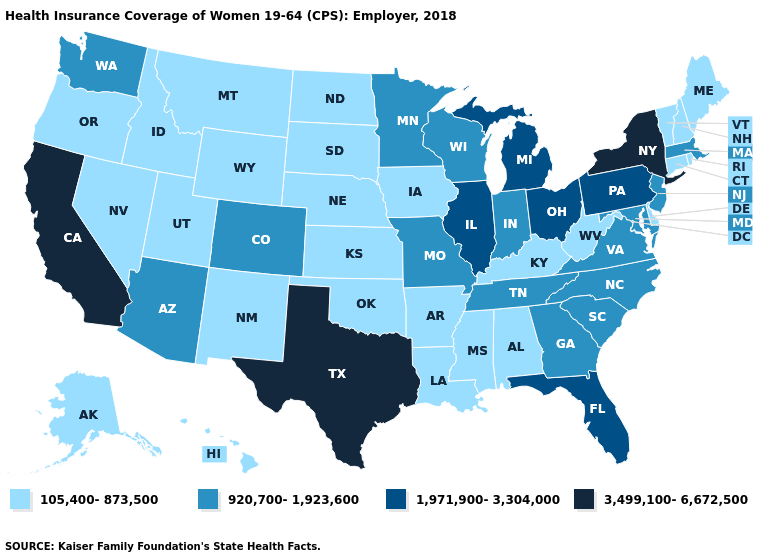What is the value of Rhode Island?
Give a very brief answer. 105,400-873,500. What is the value of Maryland?
Keep it brief. 920,700-1,923,600. Name the states that have a value in the range 3,499,100-6,672,500?
Keep it brief. California, New York, Texas. Does the first symbol in the legend represent the smallest category?
Keep it brief. Yes. Which states have the lowest value in the MidWest?
Answer briefly. Iowa, Kansas, Nebraska, North Dakota, South Dakota. Does the first symbol in the legend represent the smallest category?
Concise answer only. Yes. Name the states that have a value in the range 1,971,900-3,304,000?
Short answer required. Florida, Illinois, Michigan, Ohio, Pennsylvania. Which states hav the highest value in the Northeast?
Write a very short answer. New York. What is the value of Indiana?
Write a very short answer. 920,700-1,923,600. What is the value of Nebraska?
Keep it brief. 105,400-873,500. Name the states that have a value in the range 1,971,900-3,304,000?
Give a very brief answer. Florida, Illinois, Michigan, Ohio, Pennsylvania. Does the map have missing data?
Keep it brief. No. What is the value of Oregon?
Quick response, please. 105,400-873,500. What is the value of Georgia?
Keep it brief. 920,700-1,923,600. What is the highest value in the West ?
Short answer required. 3,499,100-6,672,500. 